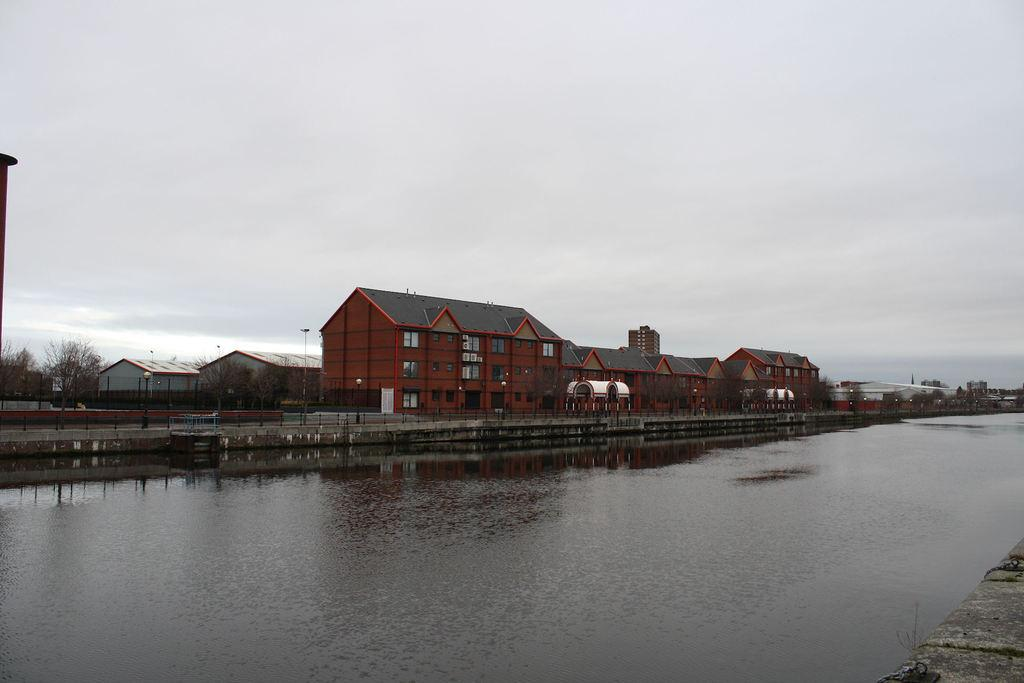What is the primary element visible in the image? There is water in the image. What type of structures can be seen in the image? There are houses in the image. What objects are present in the image besides the houses? There are poles and trees visible in the image. What can be seen in the background of the image? The sky is visible in the background of the image. What type of kettle is being used to boil water in the image? There is no kettle present in the image; it features water, houses, poles, trees, and the sky. What color is the shirt worn by the person in the image? There is no person present in the image, so it is not possible to determine the color of their shirt. 